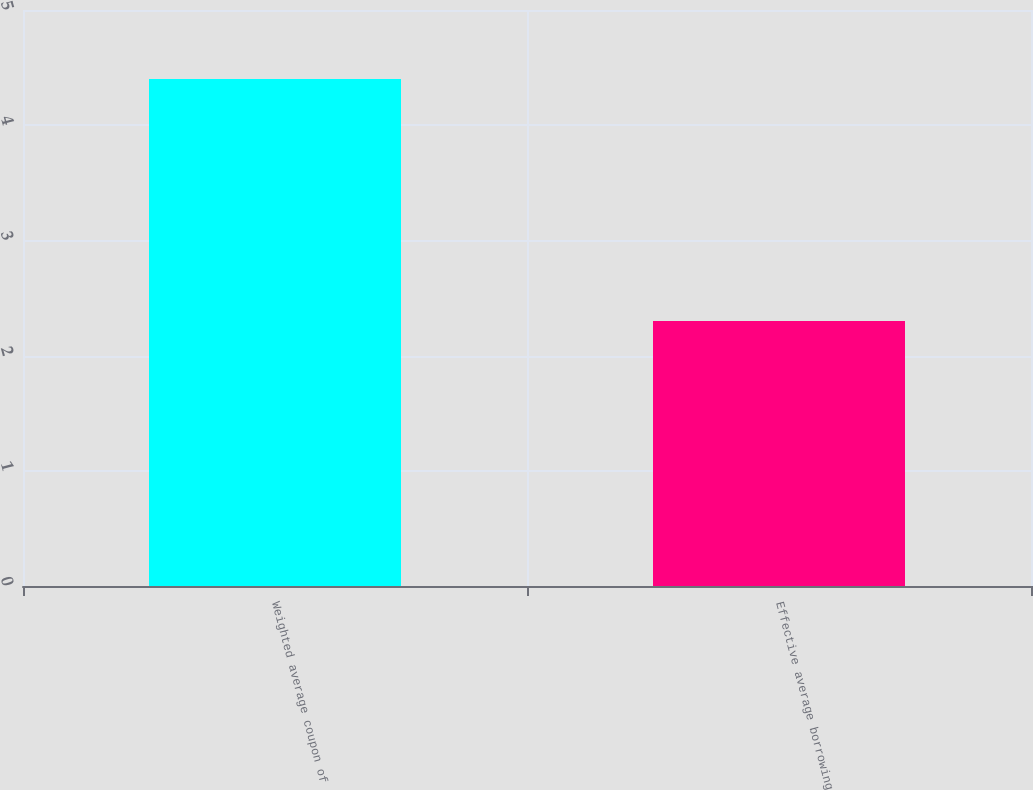Convert chart. <chart><loc_0><loc_0><loc_500><loc_500><bar_chart><fcel>Weighted average coupon of<fcel>Effective average borrowing<nl><fcel>4.4<fcel>2.3<nl></chart> 